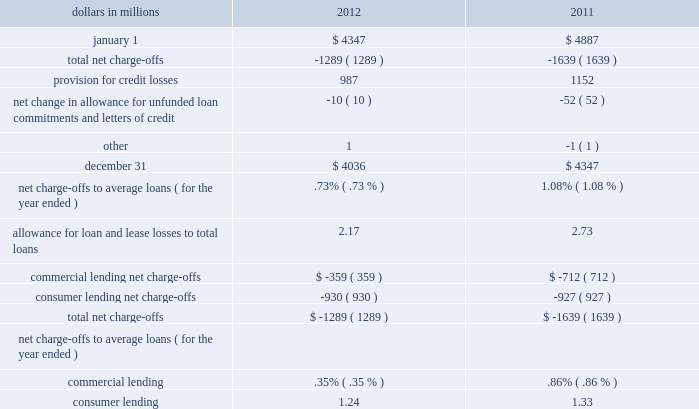Table 44 : allowance for loan and lease losses .
As further described in the consolidated income statement review section of this item 7 , the provision for credit losses totaled $ 1.0 billion for 2012 compared to $ 1.2 billion for 2011 .
For 2012 , the provision for commercial lending credit losses declined by $ 39 million or 22% ( 22 % ) from 2011 .
Similarly , the provision for consumer lending credit losses decreased $ 126 million or 13% ( 13 % ) from 2011 .
At december 31 , 2012 , total alll to total nonperforming loans was 124% ( 124 % ) .
The comparable amount for december 31 , 2011 was 122% ( 122 % ) .
These ratios are 79% ( 79 % ) and 84% ( 84 % ) , respectively , when excluding the $ 1.5 billion and $ 1.4 billion , respectively , of allowance at december 31 , 2012 and december 31 , 2011 allocated to consumer loans and lines of credit not secured by residential real estate and purchased impaired loans .
We have excluded consumer loans and lines of credit not secured by real estate as they are charged off after 120 to 180 days past due and not placed on nonperforming status .
Additionally , we have excluded purchased impaired loans as they are considered performing regardless of their delinquency status as interest is accreted based on our estimate of expected cash flows and additional allowance is recorded when these cash flows are below recorded investment .
See table 33 : nonperforming assets by type within this credit risk management section for additional information .
The alll balance increases or decreases across periods in relation to fluctuating risk factors , including asset quality trends , charge-offs and changes in aggregate portfolio balances .
During 2012 , improving asset quality trends , including , but not limited to , delinquency status , improving economic conditions , realization of previously estimated losses through charge-offs and overall portfolio growth , combined to result in reducing the estimated credit losses within the portfolio .
As a result , the alll balance declined $ 311 million , or 7% ( 7 % ) , to $ 4.0 billion during the year ended december 31 , 2012 .
See note 7 allowances for loan and lease losses and unfunded loan commitments and letters of credit and note 6 purchased loans in the notes to consolidated financial statements in item 8 of this report regarding changes in the alll and in the allowance for unfunded loan commitments and letters of credit .
Credit default swaps from a credit risk management perspective , we use credit default swaps ( cds ) as a tool to manage risk concentrations in the credit portfolio .
That risk management could come from protection purchased or sold in the form of single name or index products .
When we buy loss protection by purchasing a cds , we pay a fee to the seller , or cds counterparty , in return for the right to receive a payment if a specified credit event occurs for a particular obligor or reference entity .
When we sell protection , we receive a cds premium from the buyer in return for pnc 2019s obligation to pay the buyer if a specified credit event occurs for a particular obligor or reference entity .
We evaluate the counterparty credit worthiness for all our cds activities .
Counterparty creditworthiness is approved based on a review of credit quality in accordance with our traditional credit quality standards and credit policies .
The credit risk of our counterparties is monitored in the normal course of business .
In addition , all counterparty credit lines are subject to collateral thresholds and exposures above these thresholds are secured .
Cdss are included in the 201cderivatives not designated as hedging instruments under gaap 201d section of table 54 : financial derivatives summary in the financial derivatives section of this risk management discussion .
The pnc financial services group , inc .
2013 form 10-k 97 .
In 2012 what was the ratio of the decline in the provision for commercial lending credit losses to the consumers provision? 
Computations: (39 / 126)
Answer: 0.30952. 